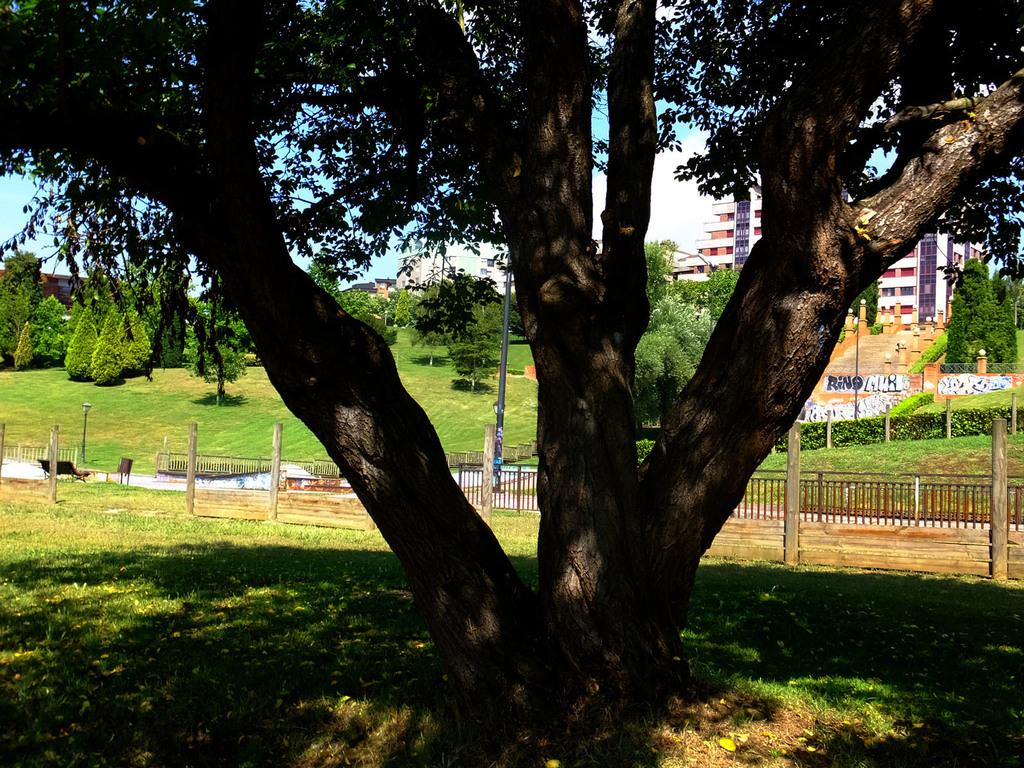What type of vegetation can be seen in the image? There are many trees in the image. What type of ground cover is present in the image? There is grass in the image. What type of barrier can be seen in the image? There is a fence in the image. What type of seating is present in the image? There is a bench in the image. What type of structure is present in the image? There is a wooden pole in the image. What type of man-made structure is present in the image? There is a building in the image. What type of architectural feature is present in the image? There are stairs in the image. What type of text can be seen in the image? There is a text in the image. What is the condition of the sky in the image? The sky is cloudy in the image. How many frogs are sitting on the bench in the image? There are no frogs present in the image; it features a bench, trees, grass, and other elements. What type of sweater is draped over the wooden pole in the image? There is no sweater present in the image; it features a wooden pole, trees, grass, and other elements. 